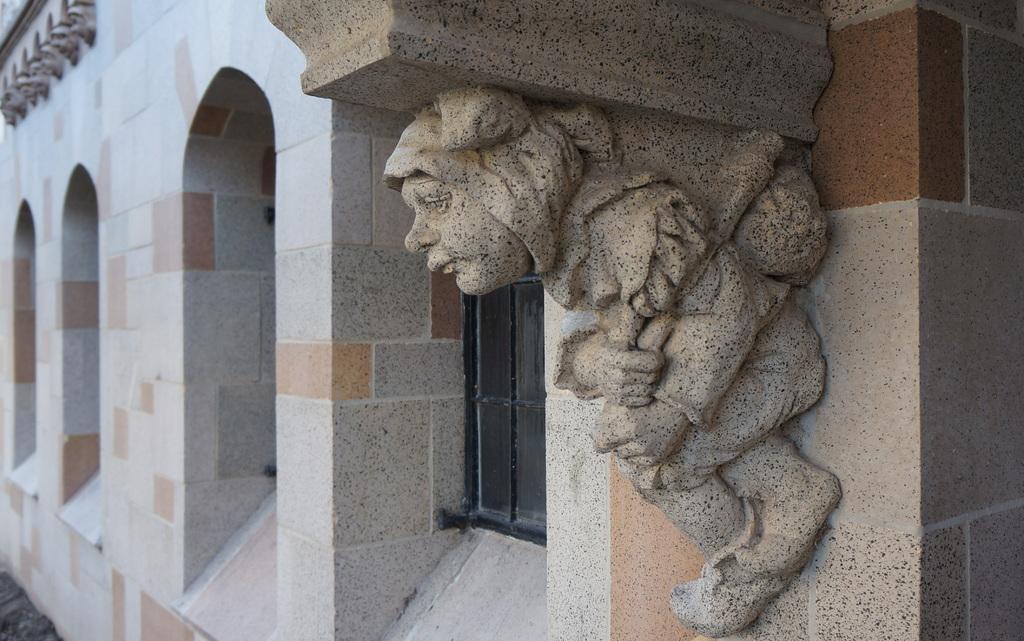Can you describe this image briefly? In this picture, we can see the wall with windows, carved object attached to the wall, and we can see the ground. 